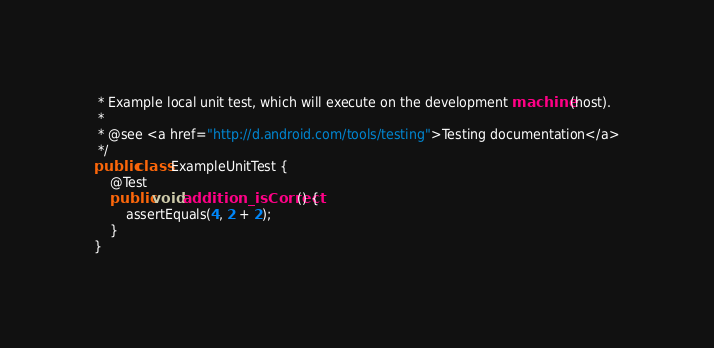Convert code to text. <code><loc_0><loc_0><loc_500><loc_500><_Java_> * Example local unit test, which will execute on the development machine (host).
 *
 * @see <a href="http://d.android.com/tools/testing">Testing documentation</a>
 */
public class ExampleUnitTest {
    @Test
    public void addition_isCorrect() {
        assertEquals(4, 2 + 2);
    }
}</code> 